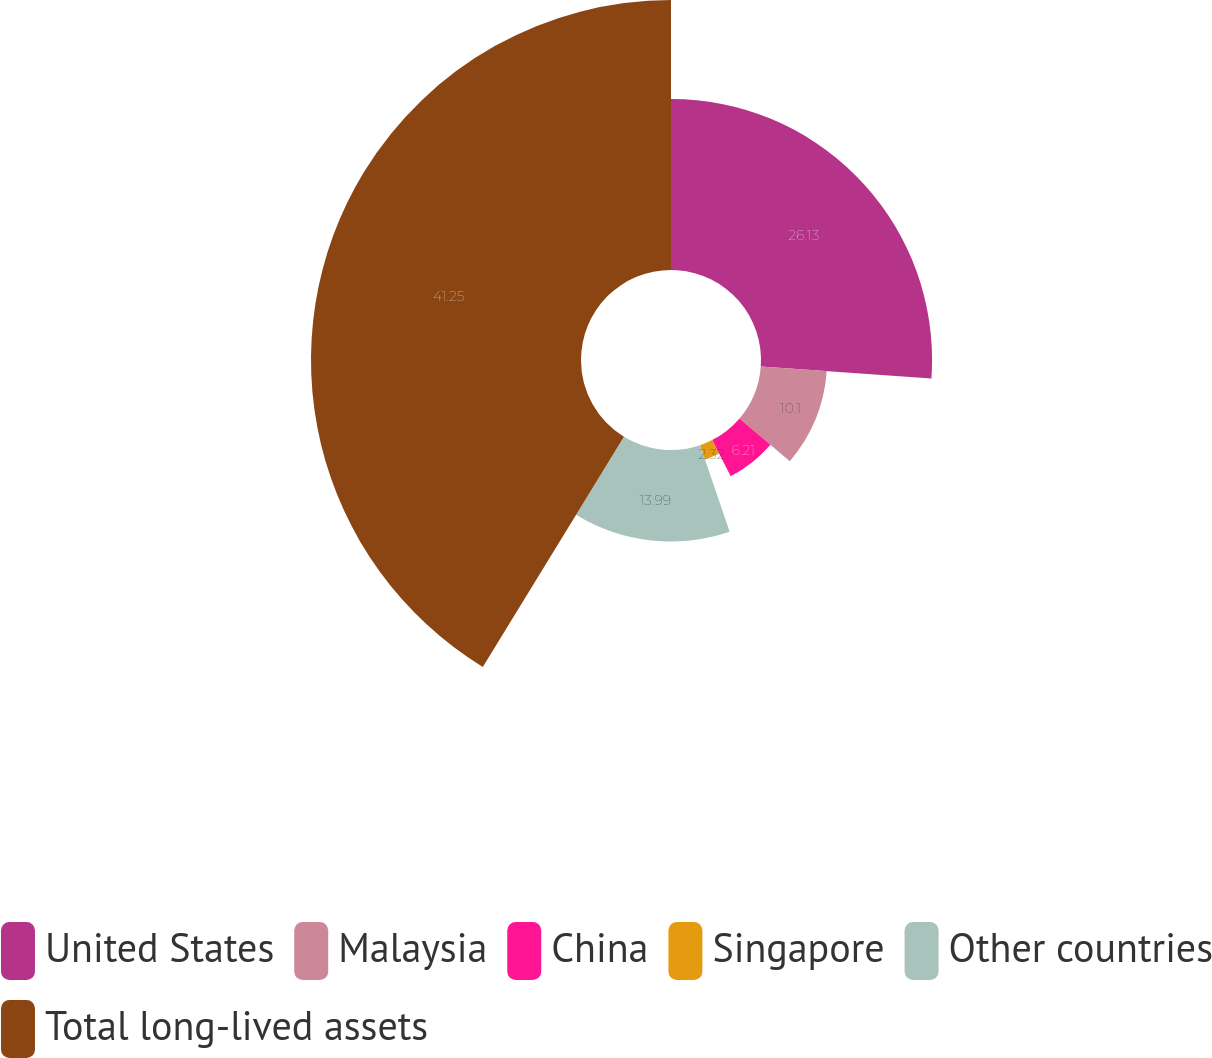Convert chart to OTSL. <chart><loc_0><loc_0><loc_500><loc_500><pie_chart><fcel>United States<fcel>Malaysia<fcel>China<fcel>Singapore<fcel>Other countries<fcel>Total long-lived assets<nl><fcel>26.13%<fcel>10.1%<fcel>6.21%<fcel>2.32%<fcel>13.99%<fcel>41.24%<nl></chart> 